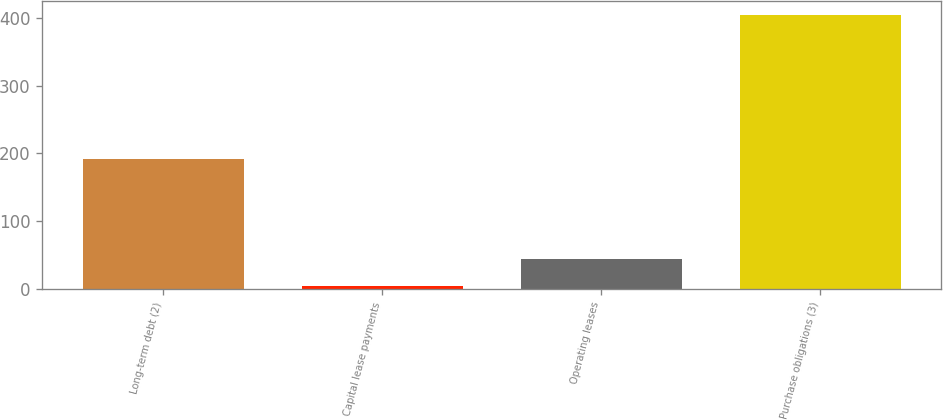<chart> <loc_0><loc_0><loc_500><loc_500><bar_chart><fcel>Long-term debt (2)<fcel>Capital lease payments<fcel>Operating leases<fcel>Purchase obligations (3)<nl><fcel>192<fcel>5<fcel>44.9<fcel>404<nl></chart> 